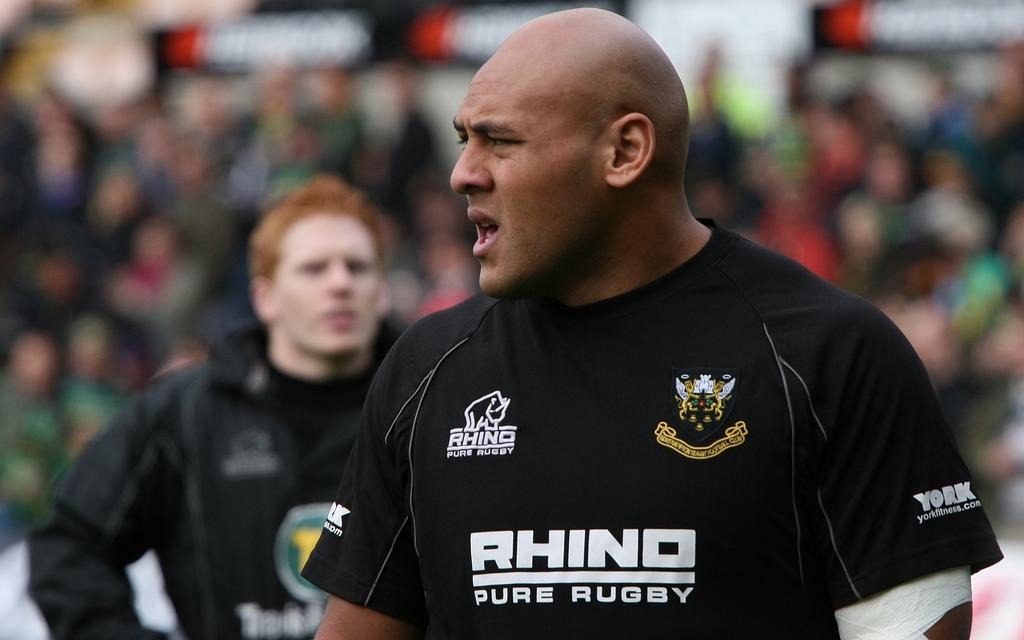<image>
Offer a succinct explanation of the picture presented. An athlete wears a jersey advertising Rhino Pure Rugby. 